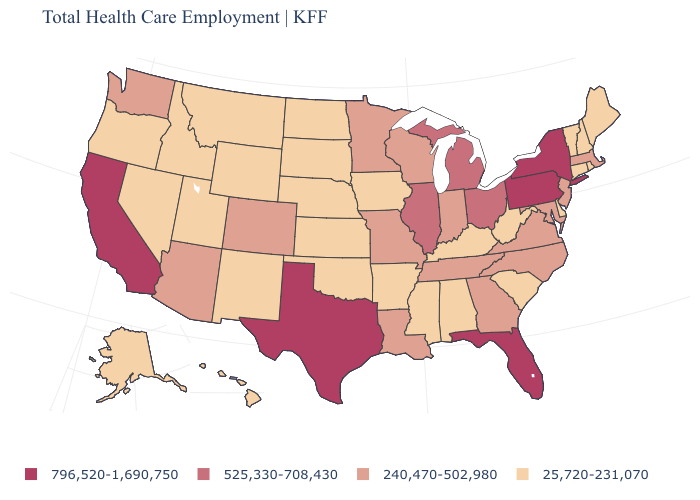How many symbols are there in the legend?
Concise answer only. 4. What is the value of South Dakota?
Keep it brief. 25,720-231,070. What is the lowest value in states that border Massachusetts?
Write a very short answer. 25,720-231,070. What is the value of Wyoming?
Quick response, please. 25,720-231,070. Does the map have missing data?
Give a very brief answer. No. What is the value of Washington?
Write a very short answer. 240,470-502,980. Which states have the lowest value in the USA?
Keep it brief. Alabama, Alaska, Arkansas, Connecticut, Delaware, Hawaii, Idaho, Iowa, Kansas, Kentucky, Maine, Mississippi, Montana, Nebraska, Nevada, New Hampshire, New Mexico, North Dakota, Oklahoma, Oregon, Rhode Island, South Carolina, South Dakota, Utah, Vermont, West Virginia, Wyoming. What is the highest value in states that border Tennessee?
Keep it brief. 240,470-502,980. Is the legend a continuous bar?
Answer briefly. No. Name the states that have a value in the range 796,520-1,690,750?
Concise answer only. California, Florida, New York, Pennsylvania, Texas. What is the lowest value in the USA?
Keep it brief. 25,720-231,070. What is the value of Florida?
Answer briefly. 796,520-1,690,750. Does Rhode Island have the lowest value in the Northeast?
Answer briefly. Yes. Does Arizona have a higher value than California?
Short answer required. No. Name the states that have a value in the range 525,330-708,430?
Concise answer only. Illinois, Michigan, Ohio. 